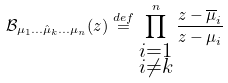<formula> <loc_0><loc_0><loc_500><loc_500>\mathcal { B } _ { \mu _ { 1 } \dots \hat { \mu } _ { k } \dots \mu _ { n } } ( z ) \stackrel { d e f } { = } \prod _ { \substack { i = 1 \\ i \not = k } } ^ { n } \frac { z - \overline { \mu } _ { i } } { z - \mu _ { i } }</formula> 